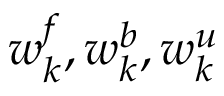<formula> <loc_0><loc_0><loc_500><loc_500>w _ { k } ^ { f } , w _ { k } ^ { b } , w _ { k } ^ { u }</formula> 